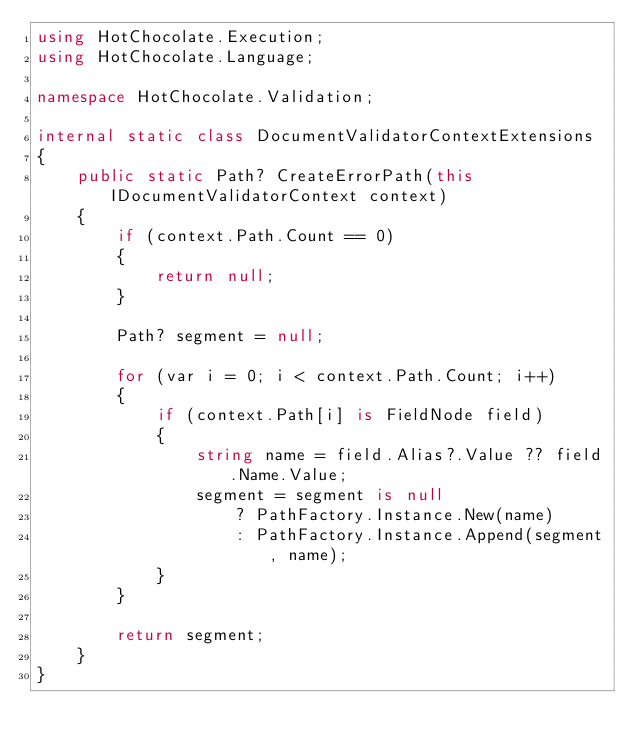Convert code to text. <code><loc_0><loc_0><loc_500><loc_500><_C#_>using HotChocolate.Execution;
using HotChocolate.Language;

namespace HotChocolate.Validation;

internal static class DocumentValidatorContextExtensions
{
    public static Path? CreateErrorPath(this IDocumentValidatorContext context)
    {
        if (context.Path.Count == 0)
        {
            return null;
        }

        Path? segment = null;

        for (var i = 0; i < context.Path.Count; i++)
        {
            if (context.Path[i] is FieldNode field)
            {
                string name = field.Alias?.Value ?? field.Name.Value;
                segment = segment is null
                    ? PathFactory.Instance.New(name)
                    : PathFactory.Instance.Append(segment, name);
            }
        }

        return segment;
    }
}
</code> 